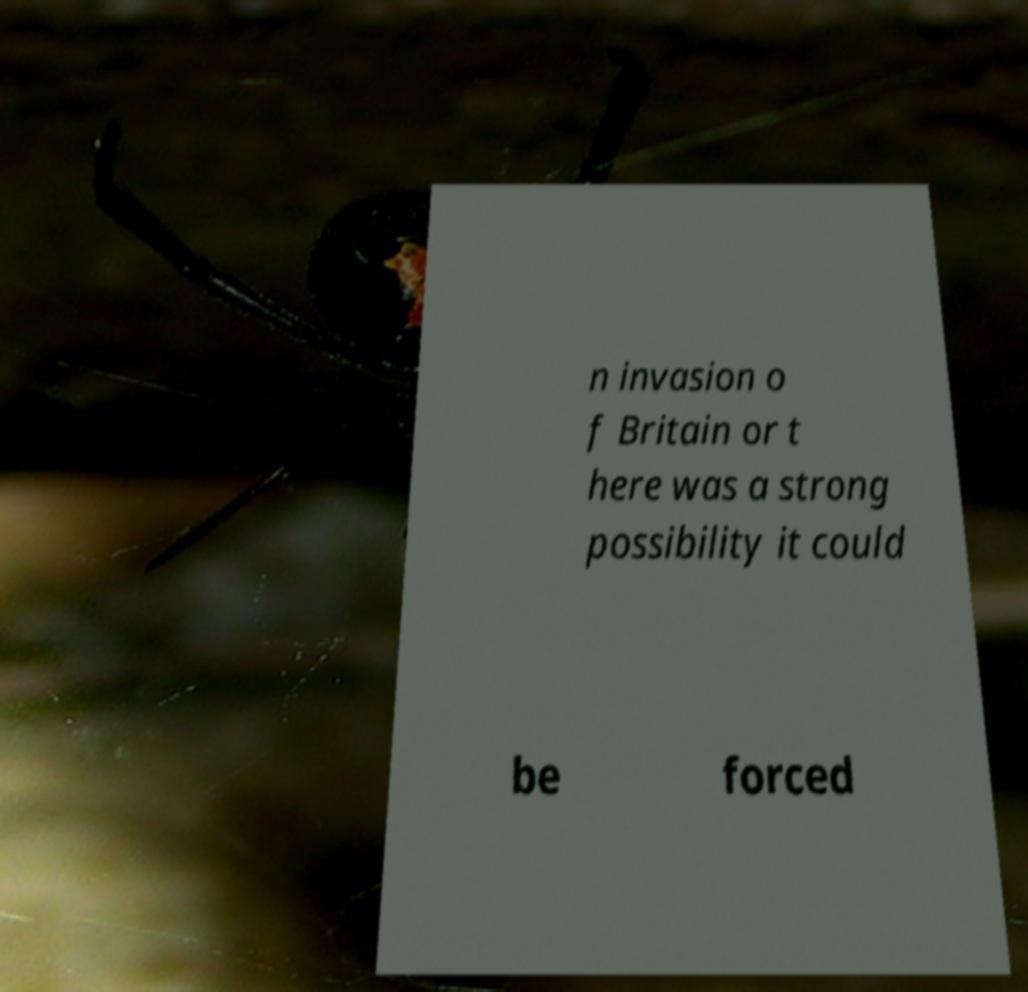Can you read and provide the text displayed in the image?This photo seems to have some interesting text. Can you extract and type it out for me? n invasion o f Britain or t here was a strong possibility it could be forced 